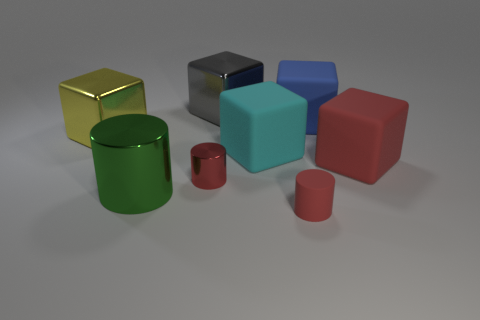Subtract 2 blocks. How many blocks are left? 3 Subtract all blue cubes. How many cubes are left? 4 Subtract all large blue blocks. How many blocks are left? 4 Subtract all green cubes. Subtract all cyan balls. How many cubes are left? 5 Add 1 large blue rubber things. How many objects exist? 9 Subtract all cylinders. How many objects are left? 5 Add 3 large red rubber things. How many large red rubber things are left? 4 Add 5 large blue blocks. How many large blue blocks exist? 6 Subtract 0 yellow spheres. How many objects are left? 8 Subtract all tiny green matte spheres. Subtract all green objects. How many objects are left? 7 